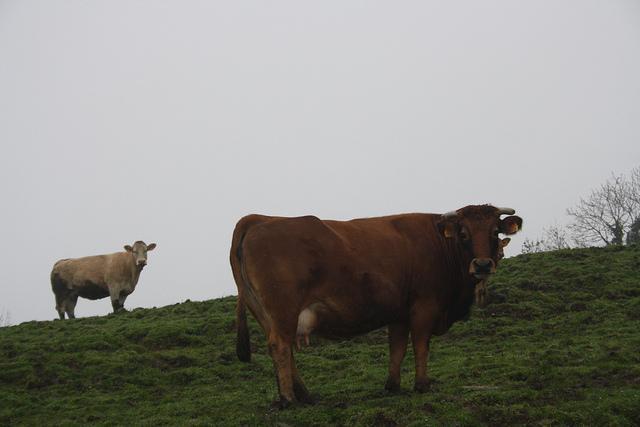How many cows are there?
Give a very brief answer. 2. How many cows are in the photo?
Give a very brief answer. 2. 